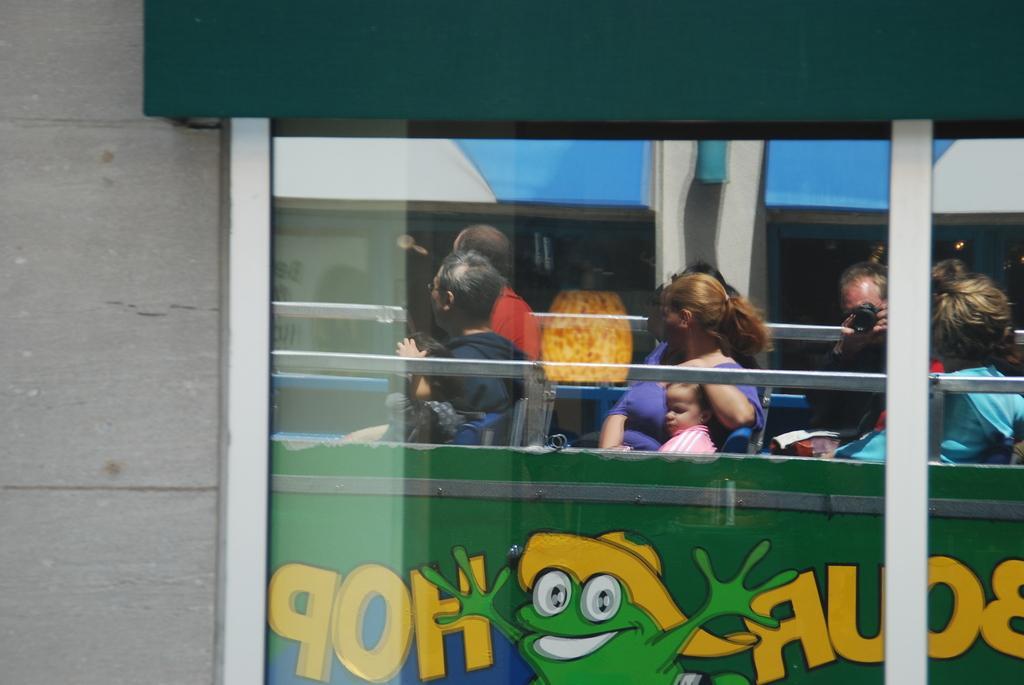In one or two sentences, can you explain what this image depicts? In this picture we can see the windows of a building and brick wall. In the window we can see the reflection of a bus, on the bus there are people sitting in seats. 